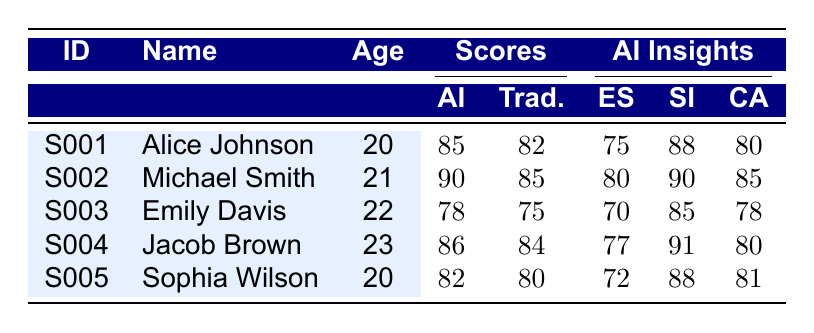What is the AI Assessment Score of Michael Smith? The AI Assessment Score for Michael Smith is provided in the table under the "AI" column next to his name, which shows a score of 90.
Answer: 90 What is the age of the student with the highest AI Assessment Score? Michael Smith has the highest AI Assessment Score of 90, and he is 21 years old, as indicated in the corresponding row for his data.
Answer: 21 What is the difference between the highest and lowest Traditional Test Scores? The highest Traditional Test Score is 85 (Michael Smith), and the lowest is 75 (Emily Davis). Therefore, the difference is 85 - 75 = 10.
Answer: 10 Which student has the highest score in Social Interest according to AI-Based Insights? Jacob Brown has the highest Social Interest score of 91, as seen in the AI-Based Insights section of his row.
Answer: Jacob Brown Is there any student with an AI Assessment Score lower than their Traditional Test Score? Yes, Emily Davis has an AI Assessment Score of 78, which is lower than her Traditional Test Score of 75.
Answer: No What is the average Emotional Stability score of all students? The Emotional Stability scores are 75, 80, 70, 77, and 72. To find the average, sum these scores (75 + 80 + 70 + 77 + 72 = 374) and divide by the number of students (374/5 = 74.8).
Answer: 74.8 Which student has a greater AI Assessment Score compared to their Traditional Test Score? Alice Johnson, Michael Smith, Jacob Brown, and Sophia Wilson all have AI Assessment Scores greater than their Traditional Test Scores, while only Emily Davis does not.
Answer: Yes What is the sum of Cognitive Agility scores for all students? The Cognitive Agility scores are 80, 85, 78, 80, and 81. Summing these gives: 80 + 85 + 78 + 80 + 81 = 404.
Answer: 404 What is the traditional test score of Sophia Wilson? The traditional test score for Sophia Wilson is listed in the table as 80, which can be found in her corresponding row.
Answer: 80 